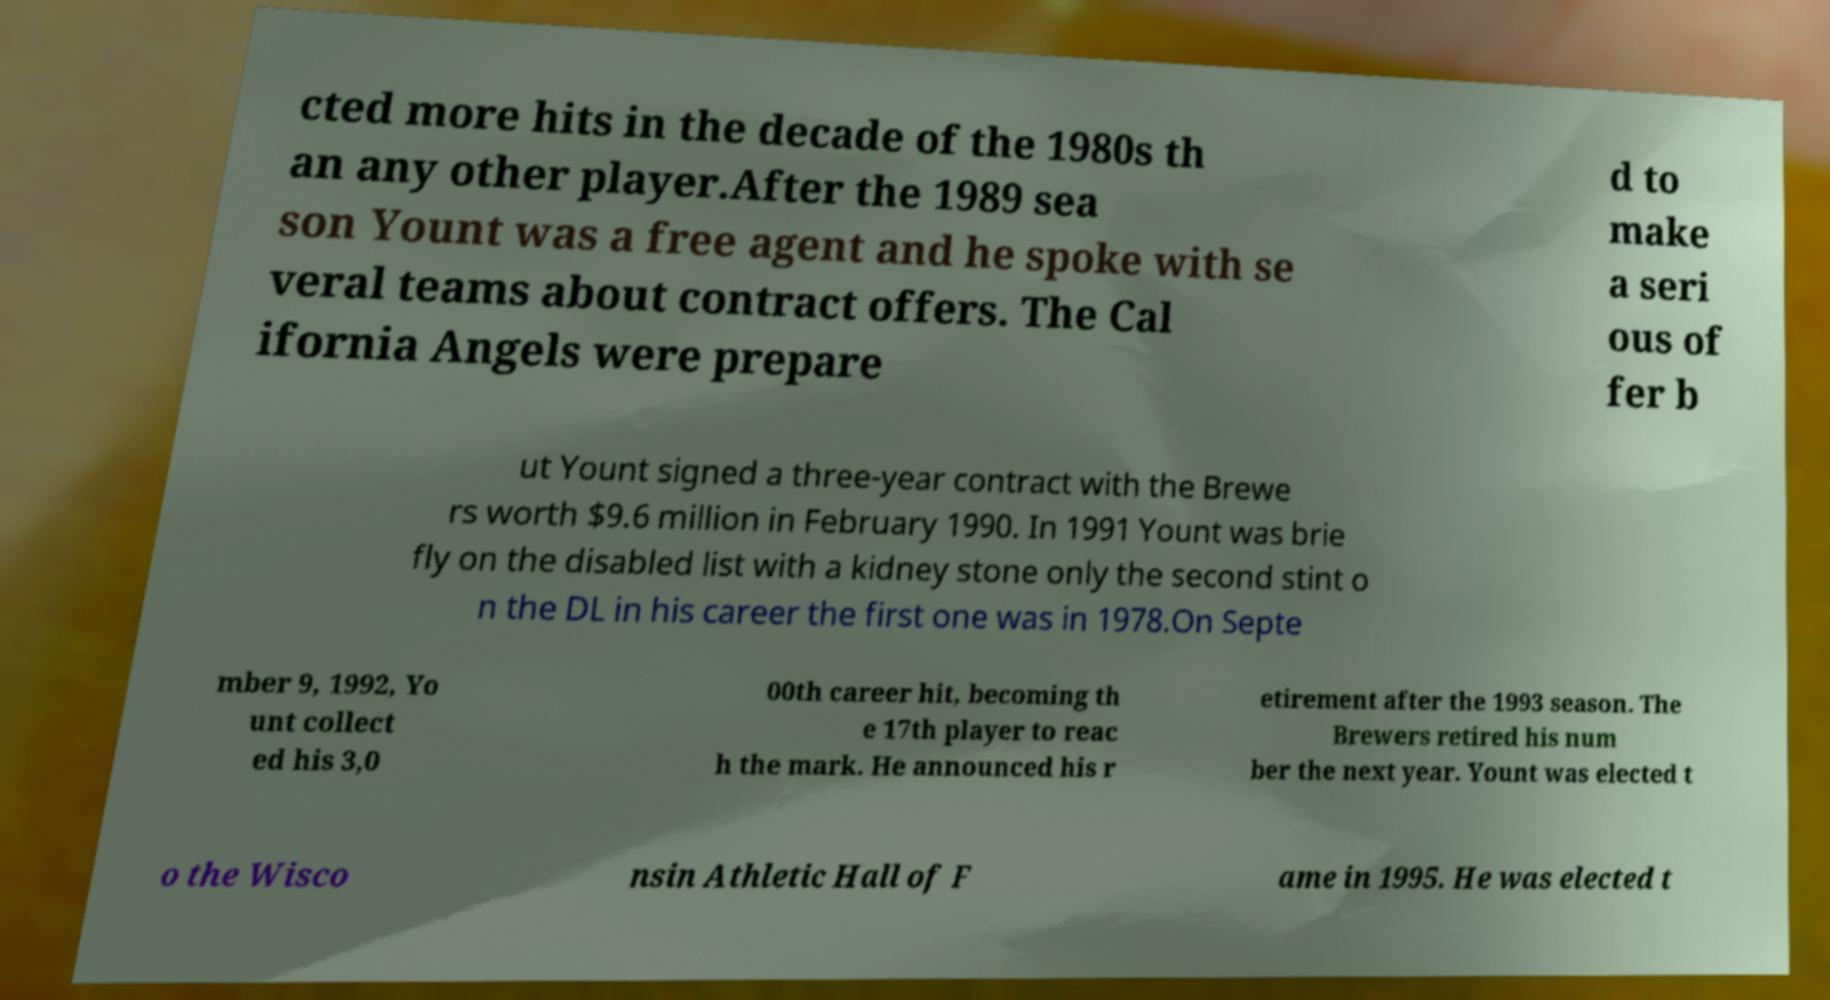What messages or text are displayed in this image? I need them in a readable, typed format. cted more hits in the decade of the 1980s th an any other player.After the 1989 sea son Yount was a free agent and he spoke with se veral teams about contract offers. The Cal ifornia Angels were prepare d to make a seri ous of fer b ut Yount signed a three-year contract with the Brewe rs worth $9.6 million in February 1990. In 1991 Yount was brie fly on the disabled list with a kidney stone only the second stint o n the DL in his career the first one was in 1978.On Septe mber 9, 1992, Yo unt collect ed his 3,0 00th career hit, becoming th e 17th player to reac h the mark. He announced his r etirement after the 1993 season. The Brewers retired his num ber the next year. Yount was elected t o the Wisco nsin Athletic Hall of F ame in 1995. He was elected t 